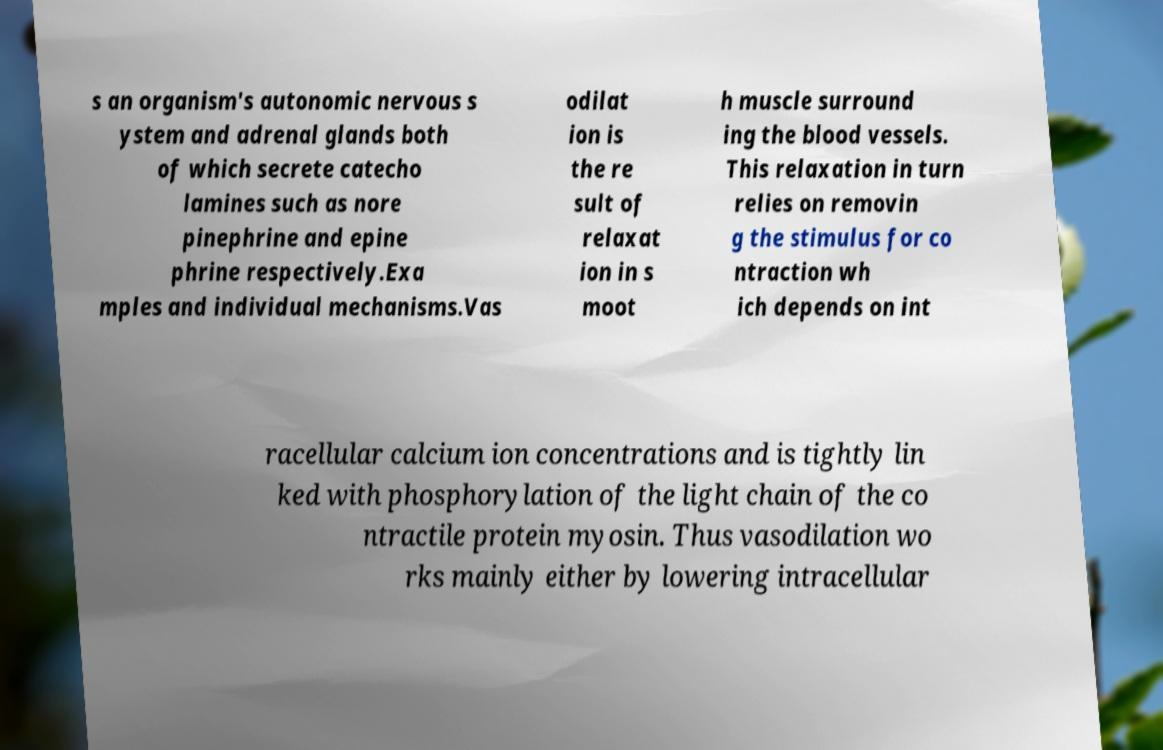Could you assist in decoding the text presented in this image and type it out clearly? s an organism's autonomic nervous s ystem and adrenal glands both of which secrete catecho lamines such as nore pinephrine and epine phrine respectively.Exa mples and individual mechanisms.Vas odilat ion is the re sult of relaxat ion in s moot h muscle surround ing the blood vessels. This relaxation in turn relies on removin g the stimulus for co ntraction wh ich depends on int racellular calcium ion concentrations and is tightly lin ked with phosphorylation of the light chain of the co ntractile protein myosin. Thus vasodilation wo rks mainly either by lowering intracellular 